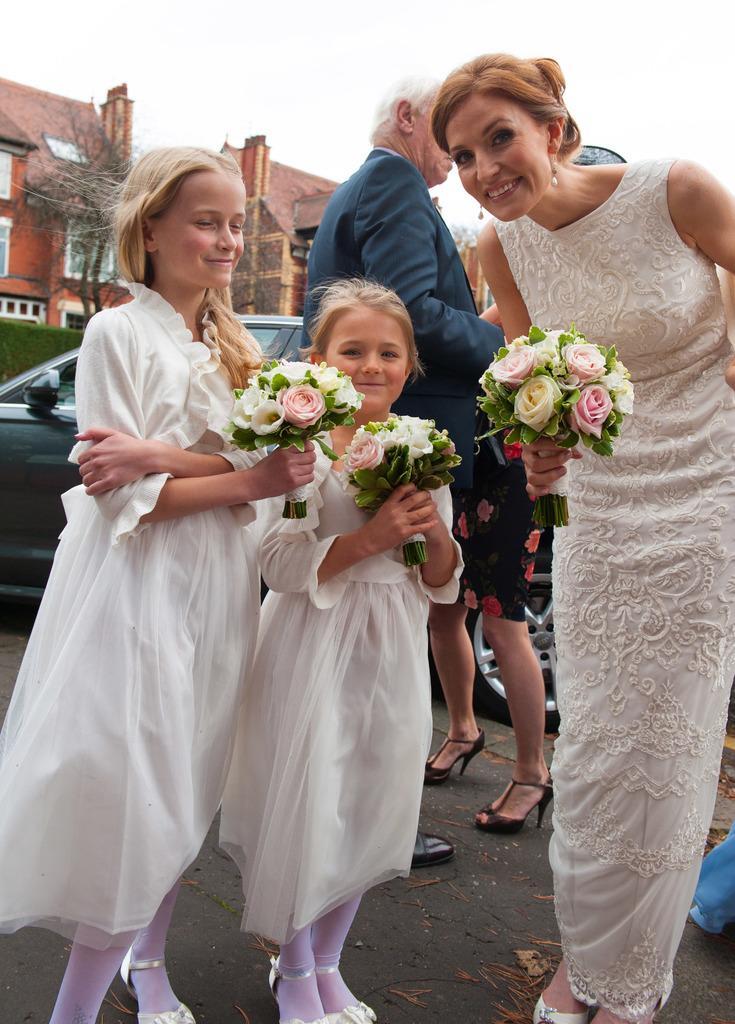Describe this image in one or two sentences. This picture is clicked outside. On the left we can see the two girls wearing white color dresses, holding bouquets and standing on the ground. On the right there is a woman wearing white color dress, holding a bouquet, smiling and standing on the ground. In the center we can see the group of persons and a vehicle. In the background we can see the sky and some houses and some other objects. 